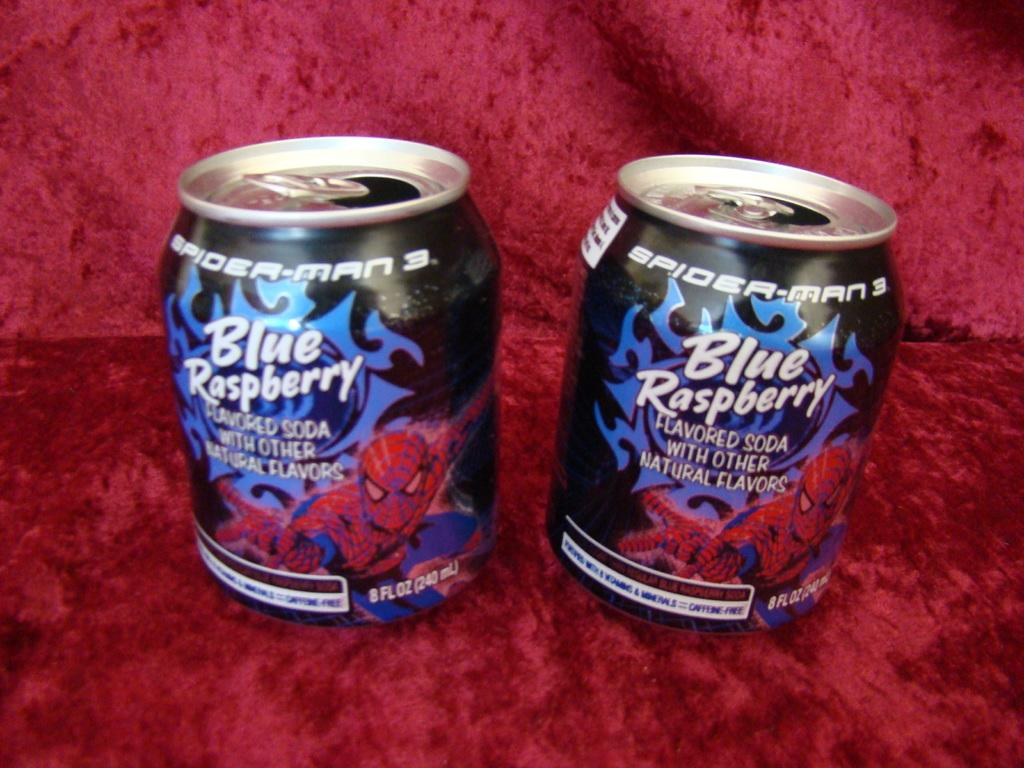<image>
Create a compact narrative representing the image presented. Two small cans of blue raspberry soda sit on a red velvet cloth. 